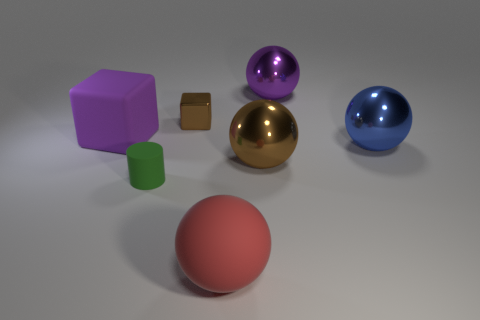Is there any other thing that is the same size as the green cylinder?
Provide a succinct answer. Yes. There is a big purple object that is the same shape as the tiny brown metal object; what is it made of?
Provide a succinct answer. Rubber. There is a large purple object on the right side of the brown cube; is it the same shape as the brown thing behind the blue metal sphere?
Provide a succinct answer. No. Is the number of large matte balls greater than the number of big objects?
Provide a succinct answer. No. What is the size of the green thing?
Provide a short and direct response. Small. How many other things are the same color as the tiny matte cylinder?
Provide a short and direct response. 0. Is the thing that is to the left of the small green object made of the same material as the small brown object?
Provide a short and direct response. No. Is the number of purple shiny balls that are in front of the big red matte object less than the number of matte blocks that are to the right of the big purple rubber object?
Ensure brevity in your answer.  No. What number of other objects are the same material as the cylinder?
Offer a terse response. 2. There is a purple thing that is the same size as the purple matte cube; what is it made of?
Your response must be concise. Metal. 